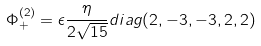Convert formula to latex. <formula><loc_0><loc_0><loc_500><loc_500>\Phi _ { + } ^ { ( 2 ) } = \epsilon { \frac { \eta } { 2 \sqrt { 1 5 } } } d i a g ( 2 , - 3 , - 3 , 2 , 2 )</formula> 